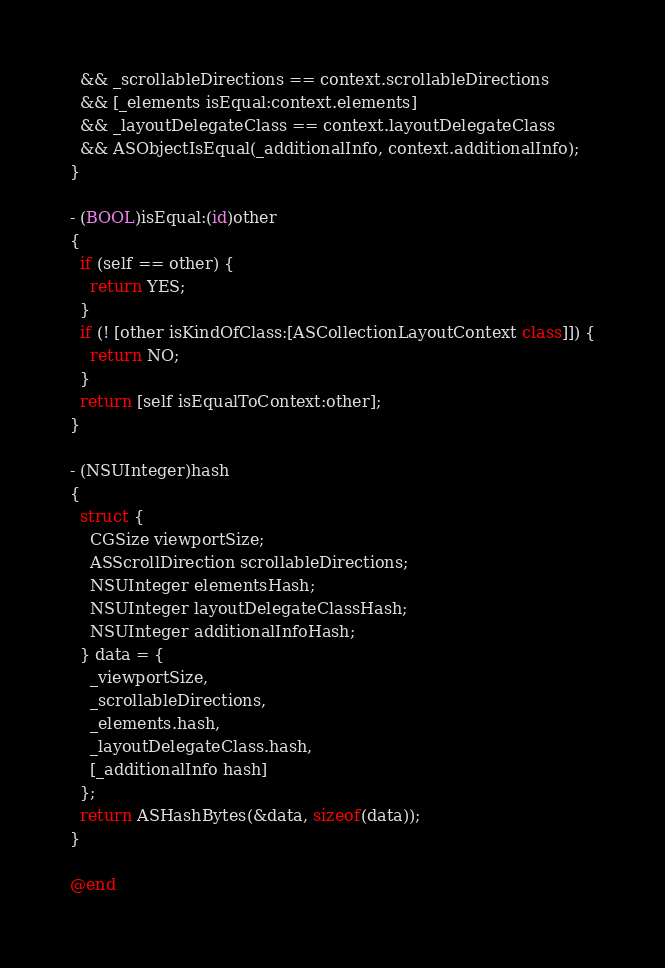<code> <loc_0><loc_0><loc_500><loc_500><_ObjectiveC_>  && _scrollableDirections == context.scrollableDirections
  && [_elements isEqual:context.elements]
  && _layoutDelegateClass == context.layoutDelegateClass
  && ASObjectIsEqual(_additionalInfo, context.additionalInfo);
}

- (BOOL)isEqual:(id)other
{
  if (self == other) {
    return YES;
  }
  if (! [other isKindOfClass:[ASCollectionLayoutContext class]]) {
    return NO;
  }
  return [self isEqualToContext:other];
}

- (NSUInteger)hash
{
  struct {
    CGSize viewportSize;
    ASScrollDirection scrollableDirections;
    NSUInteger elementsHash;
    NSUInteger layoutDelegateClassHash;
    NSUInteger additionalInfoHash;
  } data = {
    _viewportSize,
    _scrollableDirections,
    _elements.hash,
    _layoutDelegateClass.hash,
    [_additionalInfo hash]
  };
  return ASHashBytes(&data, sizeof(data));
}

@end
</code> 